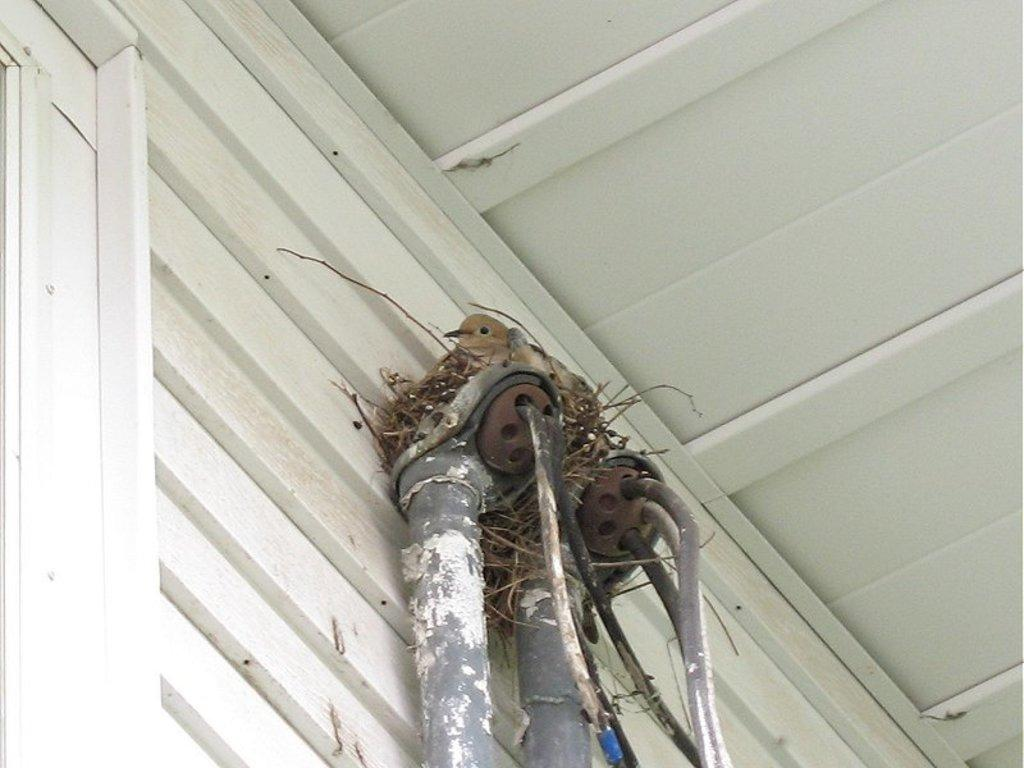What objects are present in the image? There are two pipes and a bird nest in the image. Can you describe the bird nest? The bird nest is located on top of the pipes. What color is the bird in the image? The bird is in brown color. What color shade can be seen in the image? There is a white color shade visible in the image. What type of debt is the bird trying to pay off in the image? There is no mention of debt in the image, as it features two pipes, a bird nest, and a brown bird. 